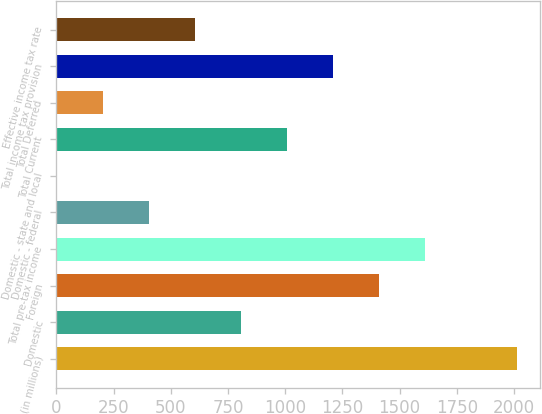Convert chart to OTSL. <chart><loc_0><loc_0><loc_500><loc_500><bar_chart><fcel>(in millions)<fcel>Domestic<fcel>Foreign<fcel>Total pre-tax income<fcel>Domestic - federal<fcel>Domestic - state and local<fcel>Total Current<fcel>Total Deferred<fcel>Total income tax provision<fcel>Effective income tax rate<nl><fcel>2011<fcel>807.4<fcel>1409.2<fcel>1609.8<fcel>406.2<fcel>5<fcel>1008<fcel>205.6<fcel>1208.6<fcel>606.8<nl></chart> 